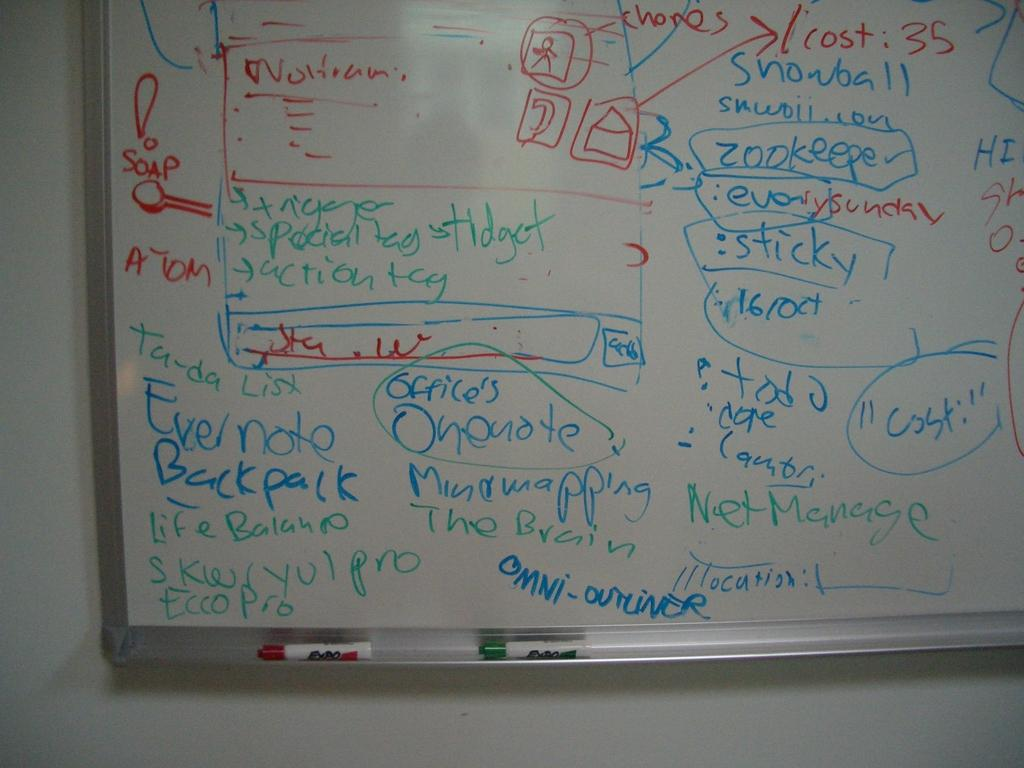<image>
Provide a brief description of the given image. A white board has the word sticky written on it. 